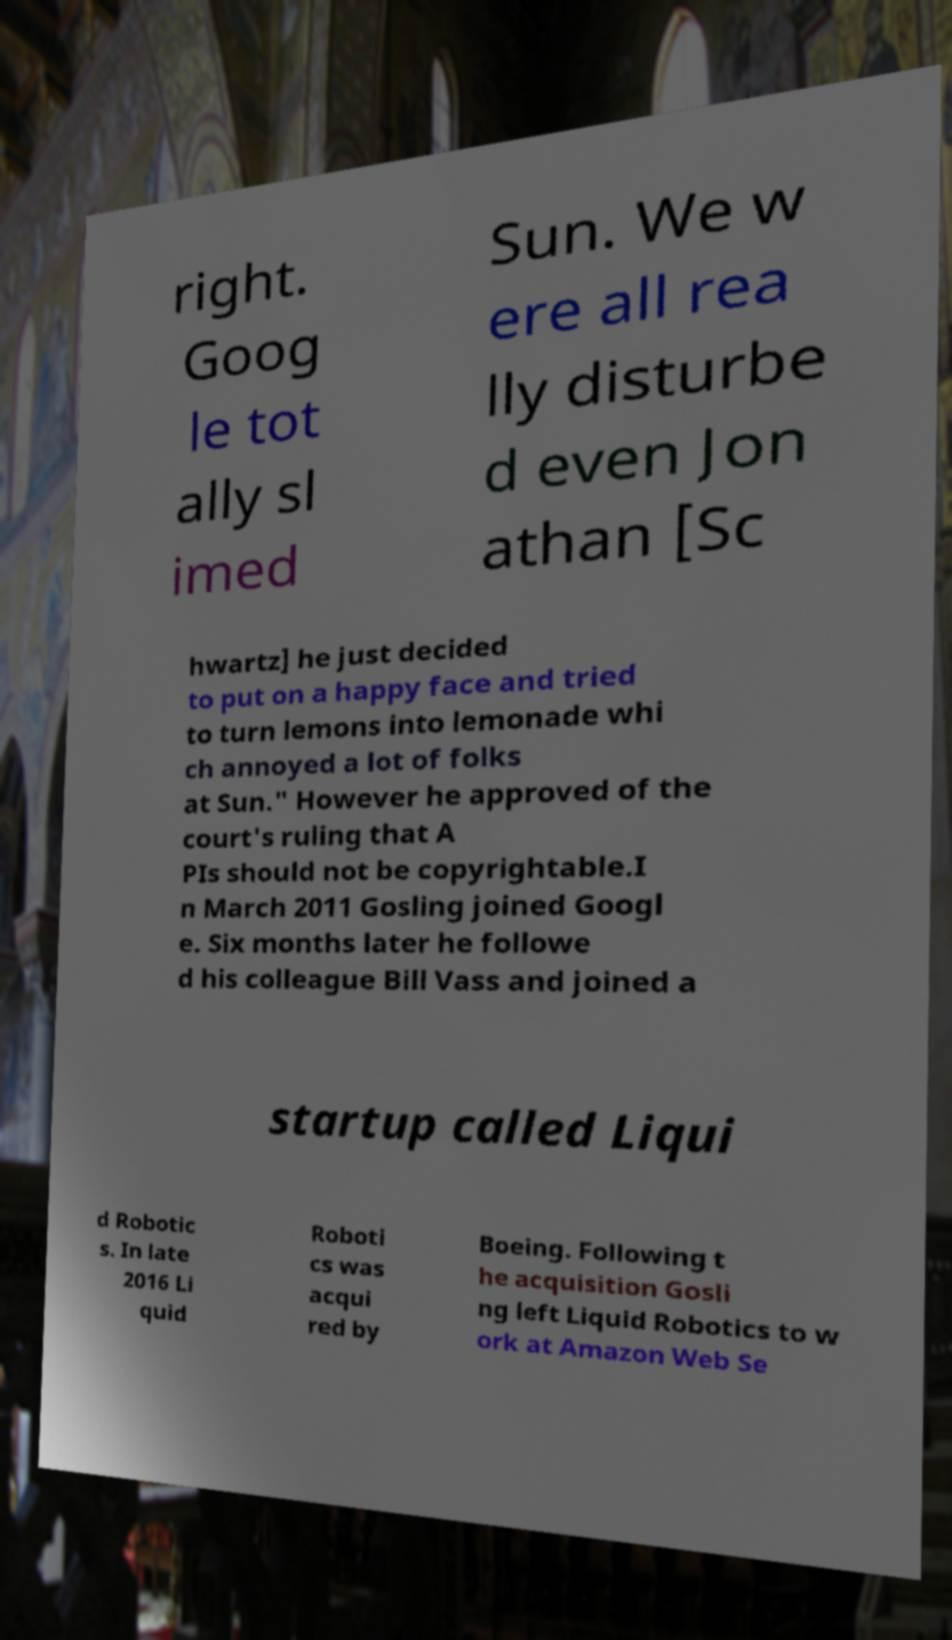Please read and relay the text visible in this image. What does it say? right. Goog le tot ally sl imed Sun. We w ere all rea lly disturbe d even Jon athan [Sc hwartz] he just decided to put on a happy face and tried to turn lemons into lemonade whi ch annoyed a lot of folks at Sun." However he approved of the court's ruling that A PIs should not be copyrightable.I n March 2011 Gosling joined Googl e. Six months later he followe d his colleague Bill Vass and joined a startup called Liqui d Robotic s. In late 2016 Li quid Roboti cs was acqui red by Boeing. Following t he acquisition Gosli ng left Liquid Robotics to w ork at Amazon Web Se 